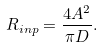<formula> <loc_0><loc_0><loc_500><loc_500>R _ { i n p } = \frac { 4 A ^ { 2 } } { \pi D } .</formula> 